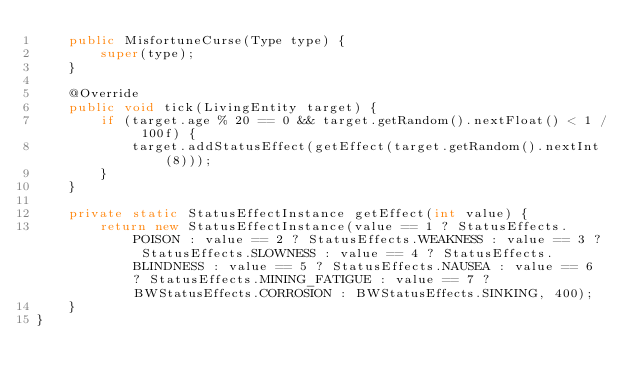Convert code to text. <code><loc_0><loc_0><loc_500><loc_500><_Java_>	public MisfortuneCurse(Type type) {
		super(type);
	}
	
	@Override
	public void tick(LivingEntity target) {
		if (target.age % 20 == 0 && target.getRandom().nextFloat() < 1 / 100f) {
			target.addStatusEffect(getEffect(target.getRandom().nextInt(8)));
		}
	}
	
	private static StatusEffectInstance getEffect(int value) {
		return new StatusEffectInstance(value == 1 ? StatusEffects.POISON : value == 2 ? StatusEffects.WEAKNESS : value == 3 ? StatusEffects.SLOWNESS : value == 4 ? StatusEffects.BLINDNESS : value == 5 ? StatusEffects.NAUSEA : value == 6 ? StatusEffects.MINING_FATIGUE : value == 7 ? BWStatusEffects.CORROSION : BWStatusEffects.SINKING, 400);
	}
}
</code> 